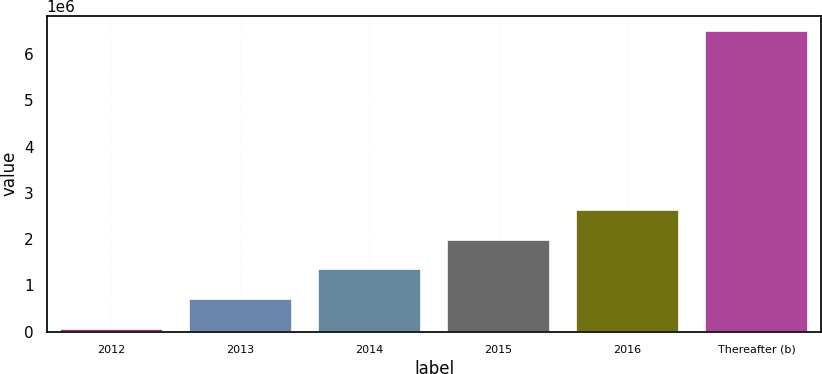<chart> <loc_0><loc_0><loc_500><loc_500><bar_chart><fcel>2012<fcel>2013<fcel>2014<fcel>2015<fcel>2016<fcel>Thereafter (b)<nl><fcel>55517<fcel>700089<fcel>1.34466e+06<fcel>1.98923e+06<fcel>2.63381e+06<fcel>6.50124e+06<nl></chart> 